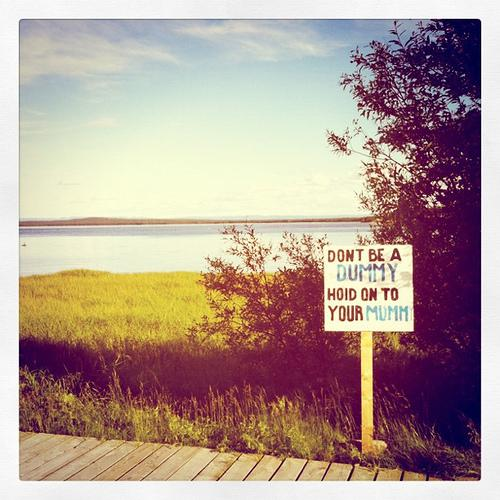Question: when was this picture taken?
Choices:
A. In the day.
B. At night.
C. At noon.
D. In the morning.
Answer with the letter. Answer: A Question: how many signs?
Choices:
A. Only one.
B. None.
C. 3.
D. 5.
Answer with the letter. Answer: A Question: what is the sign standing on?
Choices:
A. A table.
B. A wood stick.
C. On the concrete.
D. In the dirt.
Answer with the letter. Answer: B Question: why is the sign out there?
Choices:
A. To caution others.
B. To protect.
C. For warning.
D. To prevent a disaster.
Answer with the letter. Answer: C Question: where is the stick?
Choices:
A. In the dog's mouth.
B. In the dirt.
C. On the grass.
D. In the ground.
Answer with the letter. Answer: D 